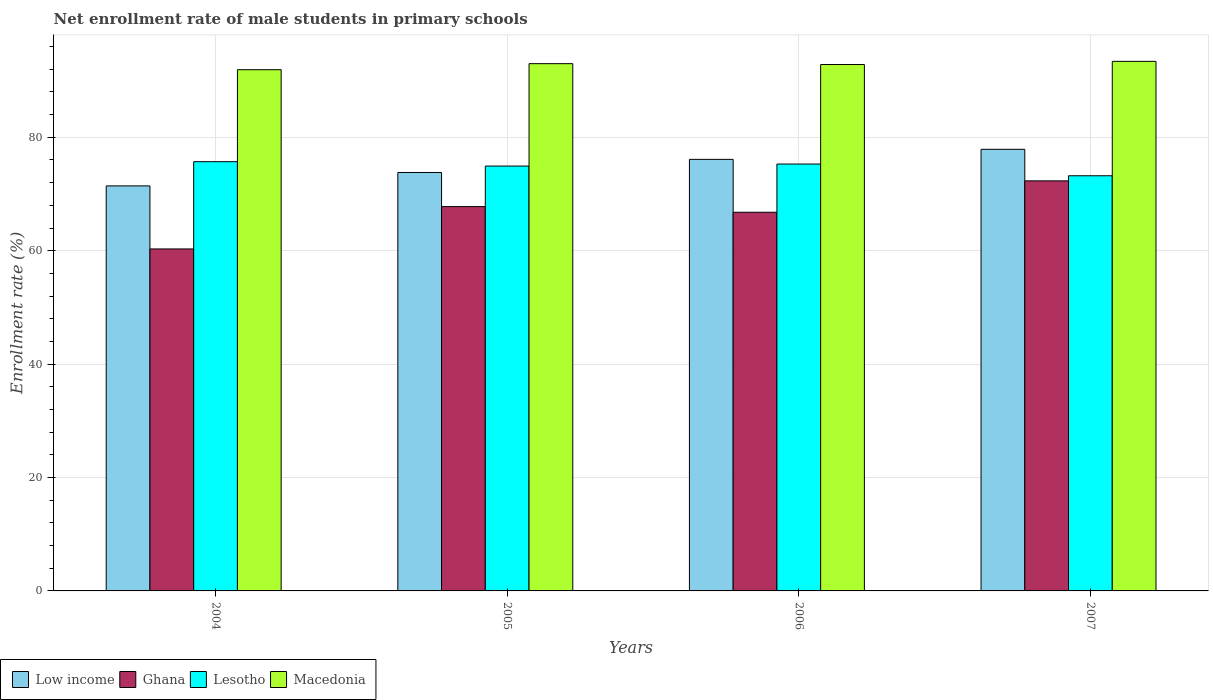How many groups of bars are there?
Your response must be concise. 4. How many bars are there on the 4th tick from the left?
Your answer should be very brief. 4. How many bars are there on the 4th tick from the right?
Provide a succinct answer. 4. What is the label of the 1st group of bars from the left?
Your answer should be very brief. 2004. What is the net enrollment rate of male students in primary schools in Ghana in 2007?
Offer a very short reply. 72.31. Across all years, what is the maximum net enrollment rate of male students in primary schools in Low income?
Offer a terse response. 77.88. Across all years, what is the minimum net enrollment rate of male students in primary schools in Lesotho?
Your response must be concise. 73.21. In which year was the net enrollment rate of male students in primary schools in Macedonia maximum?
Offer a terse response. 2007. In which year was the net enrollment rate of male students in primary schools in Low income minimum?
Your response must be concise. 2004. What is the total net enrollment rate of male students in primary schools in Macedonia in the graph?
Your response must be concise. 371.11. What is the difference between the net enrollment rate of male students in primary schools in Macedonia in 2005 and that in 2006?
Give a very brief answer. 0.15. What is the difference between the net enrollment rate of male students in primary schools in Lesotho in 2005 and the net enrollment rate of male students in primary schools in Ghana in 2004?
Provide a short and direct response. 14.62. What is the average net enrollment rate of male students in primary schools in Macedonia per year?
Give a very brief answer. 92.78. In the year 2004, what is the difference between the net enrollment rate of male students in primary schools in Macedonia and net enrollment rate of male students in primary schools in Lesotho?
Keep it short and to the point. 16.22. In how many years, is the net enrollment rate of male students in primary schools in Lesotho greater than 72 %?
Make the answer very short. 4. What is the ratio of the net enrollment rate of male students in primary schools in Lesotho in 2004 to that in 2007?
Your answer should be compact. 1.03. Is the net enrollment rate of male students in primary schools in Ghana in 2005 less than that in 2007?
Provide a succinct answer. Yes. Is the difference between the net enrollment rate of male students in primary schools in Macedonia in 2004 and 2007 greater than the difference between the net enrollment rate of male students in primary schools in Lesotho in 2004 and 2007?
Your response must be concise. No. What is the difference between the highest and the second highest net enrollment rate of male students in primary schools in Lesotho?
Provide a short and direct response. 0.42. What is the difference between the highest and the lowest net enrollment rate of male students in primary schools in Ghana?
Offer a terse response. 12. In how many years, is the net enrollment rate of male students in primary schools in Lesotho greater than the average net enrollment rate of male students in primary schools in Lesotho taken over all years?
Your answer should be very brief. 3. Is the sum of the net enrollment rate of male students in primary schools in Low income in 2006 and 2007 greater than the maximum net enrollment rate of male students in primary schools in Lesotho across all years?
Give a very brief answer. Yes. What does the 4th bar from the left in 2005 represents?
Offer a terse response. Macedonia. What does the 3rd bar from the right in 2007 represents?
Provide a succinct answer. Ghana. Is it the case that in every year, the sum of the net enrollment rate of male students in primary schools in Ghana and net enrollment rate of male students in primary schools in Lesotho is greater than the net enrollment rate of male students in primary schools in Low income?
Offer a terse response. Yes. How many bars are there?
Your response must be concise. 16. Are all the bars in the graph horizontal?
Your response must be concise. No. How many years are there in the graph?
Offer a terse response. 4. How are the legend labels stacked?
Make the answer very short. Horizontal. What is the title of the graph?
Provide a short and direct response. Net enrollment rate of male students in primary schools. Does "Burkina Faso" appear as one of the legend labels in the graph?
Ensure brevity in your answer.  No. What is the label or title of the Y-axis?
Provide a short and direct response. Enrollment rate (%). What is the Enrollment rate (%) in Low income in 2004?
Make the answer very short. 71.43. What is the Enrollment rate (%) in Ghana in 2004?
Offer a very short reply. 60.31. What is the Enrollment rate (%) in Lesotho in 2004?
Provide a short and direct response. 75.7. What is the Enrollment rate (%) of Macedonia in 2004?
Make the answer very short. 91.92. What is the Enrollment rate (%) of Low income in 2005?
Make the answer very short. 73.79. What is the Enrollment rate (%) in Ghana in 2005?
Offer a very short reply. 67.77. What is the Enrollment rate (%) in Lesotho in 2005?
Offer a terse response. 74.92. What is the Enrollment rate (%) in Macedonia in 2005?
Keep it short and to the point. 92.98. What is the Enrollment rate (%) in Low income in 2006?
Offer a very short reply. 76.1. What is the Enrollment rate (%) of Ghana in 2006?
Provide a succinct answer. 66.78. What is the Enrollment rate (%) in Lesotho in 2006?
Your answer should be compact. 75.28. What is the Enrollment rate (%) of Macedonia in 2006?
Offer a terse response. 92.83. What is the Enrollment rate (%) in Low income in 2007?
Your answer should be compact. 77.88. What is the Enrollment rate (%) of Ghana in 2007?
Ensure brevity in your answer.  72.31. What is the Enrollment rate (%) of Lesotho in 2007?
Offer a terse response. 73.21. What is the Enrollment rate (%) in Macedonia in 2007?
Provide a short and direct response. 93.39. Across all years, what is the maximum Enrollment rate (%) of Low income?
Keep it short and to the point. 77.88. Across all years, what is the maximum Enrollment rate (%) of Ghana?
Your response must be concise. 72.31. Across all years, what is the maximum Enrollment rate (%) in Lesotho?
Ensure brevity in your answer.  75.7. Across all years, what is the maximum Enrollment rate (%) of Macedonia?
Offer a terse response. 93.39. Across all years, what is the minimum Enrollment rate (%) in Low income?
Keep it short and to the point. 71.43. Across all years, what is the minimum Enrollment rate (%) in Ghana?
Keep it short and to the point. 60.31. Across all years, what is the minimum Enrollment rate (%) of Lesotho?
Your answer should be compact. 73.21. Across all years, what is the minimum Enrollment rate (%) of Macedonia?
Keep it short and to the point. 91.92. What is the total Enrollment rate (%) of Low income in the graph?
Provide a short and direct response. 299.2. What is the total Enrollment rate (%) of Ghana in the graph?
Give a very brief answer. 267.17. What is the total Enrollment rate (%) in Lesotho in the graph?
Offer a very short reply. 299.11. What is the total Enrollment rate (%) in Macedonia in the graph?
Offer a terse response. 371.11. What is the difference between the Enrollment rate (%) in Low income in 2004 and that in 2005?
Make the answer very short. -2.37. What is the difference between the Enrollment rate (%) of Ghana in 2004 and that in 2005?
Ensure brevity in your answer.  -7.46. What is the difference between the Enrollment rate (%) of Lesotho in 2004 and that in 2005?
Your answer should be compact. 0.77. What is the difference between the Enrollment rate (%) in Macedonia in 2004 and that in 2005?
Your response must be concise. -1.06. What is the difference between the Enrollment rate (%) in Low income in 2004 and that in 2006?
Your answer should be very brief. -4.68. What is the difference between the Enrollment rate (%) in Ghana in 2004 and that in 2006?
Ensure brevity in your answer.  -6.47. What is the difference between the Enrollment rate (%) of Lesotho in 2004 and that in 2006?
Your response must be concise. 0.42. What is the difference between the Enrollment rate (%) of Macedonia in 2004 and that in 2006?
Provide a succinct answer. -0.91. What is the difference between the Enrollment rate (%) in Low income in 2004 and that in 2007?
Provide a succinct answer. -6.45. What is the difference between the Enrollment rate (%) in Ghana in 2004 and that in 2007?
Offer a terse response. -12. What is the difference between the Enrollment rate (%) in Lesotho in 2004 and that in 2007?
Your response must be concise. 2.48. What is the difference between the Enrollment rate (%) of Macedonia in 2004 and that in 2007?
Your response must be concise. -1.47. What is the difference between the Enrollment rate (%) in Low income in 2005 and that in 2006?
Ensure brevity in your answer.  -2.31. What is the difference between the Enrollment rate (%) in Lesotho in 2005 and that in 2006?
Give a very brief answer. -0.35. What is the difference between the Enrollment rate (%) in Macedonia in 2005 and that in 2006?
Keep it short and to the point. 0.15. What is the difference between the Enrollment rate (%) in Low income in 2005 and that in 2007?
Provide a short and direct response. -4.09. What is the difference between the Enrollment rate (%) in Ghana in 2005 and that in 2007?
Offer a very short reply. -4.54. What is the difference between the Enrollment rate (%) in Lesotho in 2005 and that in 2007?
Offer a very short reply. 1.71. What is the difference between the Enrollment rate (%) of Macedonia in 2005 and that in 2007?
Provide a succinct answer. -0.41. What is the difference between the Enrollment rate (%) in Low income in 2006 and that in 2007?
Offer a terse response. -1.78. What is the difference between the Enrollment rate (%) in Ghana in 2006 and that in 2007?
Offer a terse response. -5.53. What is the difference between the Enrollment rate (%) in Lesotho in 2006 and that in 2007?
Your response must be concise. 2.07. What is the difference between the Enrollment rate (%) of Macedonia in 2006 and that in 2007?
Make the answer very short. -0.56. What is the difference between the Enrollment rate (%) of Low income in 2004 and the Enrollment rate (%) of Ghana in 2005?
Offer a very short reply. 3.65. What is the difference between the Enrollment rate (%) in Low income in 2004 and the Enrollment rate (%) in Lesotho in 2005?
Give a very brief answer. -3.5. What is the difference between the Enrollment rate (%) of Low income in 2004 and the Enrollment rate (%) of Macedonia in 2005?
Provide a short and direct response. -21.56. What is the difference between the Enrollment rate (%) in Ghana in 2004 and the Enrollment rate (%) in Lesotho in 2005?
Provide a short and direct response. -14.62. What is the difference between the Enrollment rate (%) in Ghana in 2004 and the Enrollment rate (%) in Macedonia in 2005?
Ensure brevity in your answer.  -32.67. What is the difference between the Enrollment rate (%) of Lesotho in 2004 and the Enrollment rate (%) of Macedonia in 2005?
Provide a short and direct response. -17.29. What is the difference between the Enrollment rate (%) in Low income in 2004 and the Enrollment rate (%) in Ghana in 2006?
Your answer should be compact. 4.65. What is the difference between the Enrollment rate (%) of Low income in 2004 and the Enrollment rate (%) of Lesotho in 2006?
Give a very brief answer. -3.85. What is the difference between the Enrollment rate (%) of Low income in 2004 and the Enrollment rate (%) of Macedonia in 2006?
Provide a short and direct response. -21.4. What is the difference between the Enrollment rate (%) in Ghana in 2004 and the Enrollment rate (%) in Lesotho in 2006?
Provide a succinct answer. -14.97. What is the difference between the Enrollment rate (%) of Ghana in 2004 and the Enrollment rate (%) of Macedonia in 2006?
Provide a short and direct response. -32.52. What is the difference between the Enrollment rate (%) of Lesotho in 2004 and the Enrollment rate (%) of Macedonia in 2006?
Provide a short and direct response. -17.13. What is the difference between the Enrollment rate (%) in Low income in 2004 and the Enrollment rate (%) in Ghana in 2007?
Provide a short and direct response. -0.89. What is the difference between the Enrollment rate (%) of Low income in 2004 and the Enrollment rate (%) of Lesotho in 2007?
Ensure brevity in your answer.  -1.79. What is the difference between the Enrollment rate (%) in Low income in 2004 and the Enrollment rate (%) in Macedonia in 2007?
Offer a very short reply. -21.96. What is the difference between the Enrollment rate (%) of Ghana in 2004 and the Enrollment rate (%) of Lesotho in 2007?
Provide a short and direct response. -12.9. What is the difference between the Enrollment rate (%) in Ghana in 2004 and the Enrollment rate (%) in Macedonia in 2007?
Your answer should be compact. -33.08. What is the difference between the Enrollment rate (%) in Lesotho in 2004 and the Enrollment rate (%) in Macedonia in 2007?
Give a very brief answer. -17.69. What is the difference between the Enrollment rate (%) in Low income in 2005 and the Enrollment rate (%) in Ghana in 2006?
Make the answer very short. 7.01. What is the difference between the Enrollment rate (%) of Low income in 2005 and the Enrollment rate (%) of Lesotho in 2006?
Your response must be concise. -1.49. What is the difference between the Enrollment rate (%) of Low income in 2005 and the Enrollment rate (%) of Macedonia in 2006?
Provide a succinct answer. -19.04. What is the difference between the Enrollment rate (%) in Ghana in 2005 and the Enrollment rate (%) in Lesotho in 2006?
Offer a terse response. -7.51. What is the difference between the Enrollment rate (%) in Ghana in 2005 and the Enrollment rate (%) in Macedonia in 2006?
Provide a short and direct response. -25.06. What is the difference between the Enrollment rate (%) of Lesotho in 2005 and the Enrollment rate (%) of Macedonia in 2006?
Ensure brevity in your answer.  -17.9. What is the difference between the Enrollment rate (%) in Low income in 2005 and the Enrollment rate (%) in Ghana in 2007?
Make the answer very short. 1.48. What is the difference between the Enrollment rate (%) of Low income in 2005 and the Enrollment rate (%) of Lesotho in 2007?
Give a very brief answer. 0.58. What is the difference between the Enrollment rate (%) in Low income in 2005 and the Enrollment rate (%) in Macedonia in 2007?
Give a very brief answer. -19.6. What is the difference between the Enrollment rate (%) of Ghana in 2005 and the Enrollment rate (%) of Lesotho in 2007?
Make the answer very short. -5.44. What is the difference between the Enrollment rate (%) in Ghana in 2005 and the Enrollment rate (%) in Macedonia in 2007?
Keep it short and to the point. -25.61. What is the difference between the Enrollment rate (%) in Lesotho in 2005 and the Enrollment rate (%) in Macedonia in 2007?
Ensure brevity in your answer.  -18.46. What is the difference between the Enrollment rate (%) in Low income in 2006 and the Enrollment rate (%) in Ghana in 2007?
Your response must be concise. 3.79. What is the difference between the Enrollment rate (%) in Low income in 2006 and the Enrollment rate (%) in Lesotho in 2007?
Provide a short and direct response. 2.89. What is the difference between the Enrollment rate (%) of Low income in 2006 and the Enrollment rate (%) of Macedonia in 2007?
Ensure brevity in your answer.  -17.28. What is the difference between the Enrollment rate (%) in Ghana in 2006 and the Enrollment rate (%) in Lesotho in 2007?
Offer a terse response. -6.44. What is the difference between the Enrollment rate (%) in Ghana in 2006 and the Enrollment rate (%) in Macedonia in 2007?
Give a very brief answer. -26.61. What is the difference between the Enrollment rate (%) in Lesotho in 2006 and the Enrollment rate (%) in Macedonia in 2007?
Offer a terse response. -18.11. What is the average Enrollment rate (%) of Low income per year?
Your answer should be compact. 74.8. What is the average Enrollment rate (%) in Ghana per year?
Make the answer very short. 66.79. What is the average Enrollment rate (%) of Lesotho per year?
Provide a succinct answer. 74.78. What is the average Enrollment rate (%) in Macedonia per year?
Give a very brief answer. 92.78. In the year 2004, what is the difference between the Enrollment rate (%) of Low income and Enrollment rate (%) of Ghana?
Your answer should be compact. 11.12. In the year 2004, what is the difference between the Enrollment rate (%) in Low income and Enrollment rate (%) in Lesotho?
Your answer should be very brief. -4.27. In the year 2004, what is the difference between the Enrollment rate (%) in Low income and Enrollment rate (%) in Macedonia?
Keep it short and to the point. -20.49. In the year 2004, what is the difference between the Enrollment rate (%) in Ghana and Enrollment rate (%) in Lesotho?
Provide a short and direct response. -15.39. In the year 2004, what is the difference between the Enrollment rate (%) in Ghana and Enrollment rate (%) in Macedonia?
Keep it short and to the point. -31.61. In the year 2004, what is the difference between the Enrollment rate (%) in Lesotho and Enrollment rate (%) in Macedonia?
Your answer should be very brief. -16.22. In the year 2005, what is the difference between the Enrollment rate (%) in Low income and Enrollment rate (%) in Ghana?
Your answer should be very brief. 6.02. In the year 2005, what is the difference between the Enrollment rate (%) of Low income and Enrollment rate (%) of Lesotho?
Provide a succinct answer. -1.13. In the year 2005, what is the difference between the Enrollment rate (%) of Low income and Enrollment rate (%) of Macedonia?
Ensure brevity in your answer.  -19.19. In the year 2005, what is the difference between the Enrollment rate (%) in Ghana and Enrollment rate (%) in Lesotho?
Make the answer very short. -7.15. In the year 2005, what is the difference between the Enrollment rate (%) in Ghana and Enrollment rate (%) in Macedonia?
Give a very brief answer. -25.21. In the year 2005, what is the difference between the Enrollment rate (%) of Lesotho and Enrollment rate (%) of Macedonia?
Provide a succinct answer. -18.06. In the year 2006, what is the difference between the Enrollment rate (%) in Low income and Enrollment rate (%) in Ghana?
Offer a very short reply. 9.33. In the year 2006, what is the difference between the Enrollment rate (%) in Low income and Enrollment rate (%) in Lesotho?
Keep it short and to the point. 0.82. In the year 2006, what is the difference between the Enrollment rate (%) of Low income and Enrollment rate (%) of Macedonia?
Provide a succinct answer. -16.73. In the year 2006, what is the difference between the Enrollment rate (%) of Ghana and Enrollment rate (%) of Lesotho?
Offer a very short reply. -8.5. In the year 2006, what is the difference between the Enrollment rate (%) in Ghana and Enrollment rate (%) in Macedonia?
Ensure brevity in your answer.  -26.05. In the year 2006, what is the difference between the Enrollment rate (%) in Lesotho and Enrollment rate (%) in Macedonia?
Give a very brief answer. -17.55. In the year 2007, what is the difference between the Enrollment rate (%) in Low income and Enrollment rate (%) in Ghana?
Provide a succinct answer. 5.57. In the year 2007, what is the difference between the Enrollment rate (%) in Low income and Enrollment rate (%) in Lesotho?
Offer a very short reply. 4.67. In the year 2007, what is the difference between the Enrollment rate (%) in Low income and Enrollment rate (%) in Macedonia?
Offer a very short reply. -15.51. In the year 2007, what is the difference between the Enrollment rate (%) of Ghana and Enrollment rate (%) of Lesotho?
Offer a very short reply. -0.9. In the year 2007, what is the difference between the Enrollment rate (%) in Ghana and Enrollment rate (%) in Macedonia?
Keep it short and to the point. -21.08. In the year 2007, what is the difference between the Enrollment rate (%) in Lesotho and Enrollment rate (%) in Macedonia?
Keep it short and to the point. -20.18. What is the ratio of the Enrollment rate (%) in Low income in 2004 to that in 2005?
Make the answer very short. 0.97. What is the ratio of the Enrollment rate (%) in Ghana in 2004 to that in 2005?
Your answer should be compact. 0.89. What is the ratio of the Enrollment rate (%) of Lesotho in 2004 to that in 2005?
Make the answer very short. 1.01. What is the ratio of the Enrollment rate (%) in Low income in 2004 to that in 2006?
Keep it short and to the point. 0.94. What is the ratio of the Enrollment rate (%) of Ghana in 2004 to that in 2006?
Your answer should be compact. 0.9. What is the ratio of the Enrollment rate (%) of Lesotho in 2004 to that in 2006?
Give a very brief answer. 1.01. What is the ratio of the Enrollment rate (%) in Macedonia in 2004 to that in 2006?
Offer a very short reply. 0.99. What is the ratio of the Enrollment rate (%) of Low income in 2004 to that in 2007?
Your answer should be very brief. 0.92. What is the ratio of the Enrollment rate (%) in Ghana in 2004 to that in 2007?
Ensure brevity in your answer.  0.83. What is the ratio of the Enrollment rate (%) in Lesotho in 2004 to that in 2007?
Provide a succinct answer. 1.03. What is the ratio of the Enrollment rate (%) in Macedonia in 2004 to that in 2007?
Your answer should be compact. 0.98. What is the ratio of the Enrollment rate (%) in Low income in 2005 to that in 2006?
Your answer should be very brief. 0.97. What is the ratio of the Enrollment rate (%) in Ghana in 2005 to that in 2006?
Provide a short and direct response. 1.01. What is the ratio of the Enrollment rate (%) of Macedonia in 2005 to that in 2006?
Keep it short and to the point. 1. What is the ratio of the Enrollment rate (%) in Low income in 2005 to that in 2007?
Your answer should be very brief. 0.95. What is the ratio of the Enrollment rate (%) of Ghana in 2005 to that in 2007?
Provide a short and direct response. 0.94. What is the ratio of the Enrollment rate (%) of Lesotho in 2005 to that in 2007?
Make the answer very short. 1.02. What is the ratio of the Enrollment rate (%) of Macedonia in 2005 to that in 2007?
Your answer should be very brief. 1. What is the ratio of the Enrollment rate (%) of Low income in 2006 to that in 2007?
Offer a very short reply. 0.98. What is the ratio of the Enrollment rate (%) of Ghana in 2006 to that in 2007?
Your answer should be very brief. 0.92. What is the ratio of the Enrollment rate (%) in Lesotho in 2006 to that in 2007?
Offer a terse response. 1.03. What is the ratio of the Enrollment rate (%) in Macedonia in 2006 to that in 2007?
Your answer should be compact. 0.99. What is the difference between the highest and the second highest Enrollment rate (%) in Low income?
Offer a terse response. 1.78. What is the difference between the highest and the second highest Enrollment rate (%) of Ghana?
Your answer should be compact. 4.54. What is the difference between the highest and the second highest Enrollment rate (%) in Lesotho?
Offer a terse response. 0.42. What is the difference between the highest and the second highest Enrollment rate (%) of Macedonia?
Your answer should be compact. 0.41. What is the difference between the highest and the lowest Enrollment rate (%) in Low income?
Make the answer very short. 6.45. What is the difference between the highest and the lowest Enrollment rate (%) in Ghana?
Give a very brief answer. 12. What is the difference between the highest and the lowest Enrollment rate (%) in Lesotho?
Offer a very short reply. 2.48. What is the difference between the highest and the lowest Enrollment rate (%) in Macedonia?
Offer a terse response. 1.47. 